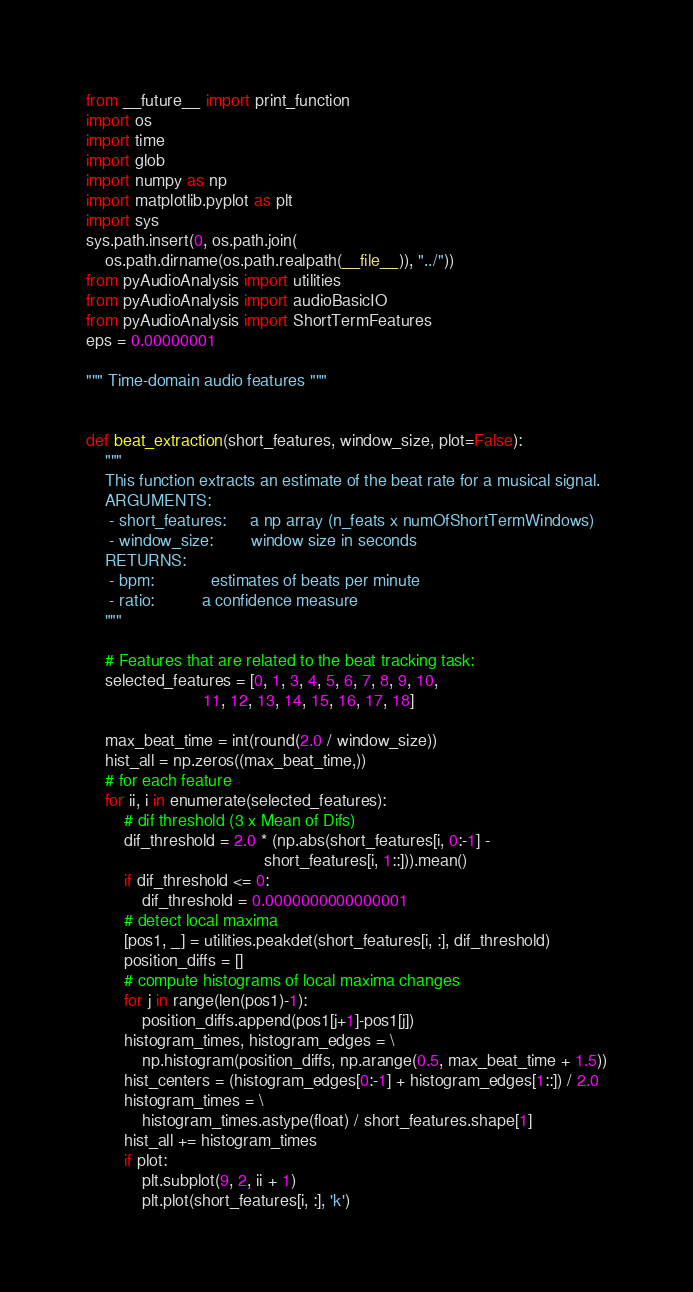Convert code to text. <code><loc_0><loc_0><loc_500><loc_500><_Python_>from __future__ import print_function
import os
import time
import glob
import numpy as np
import matplotlib.pyplot as plt
import sys
sys.path.insert(0, os.path.join(
    os.path.dirname(os.path.realpath(__file__)), "../"))
from pyAudioAnalysis import utilities
from pyAudioAnalysis import audioBasicIO
from pyAudioAnalysis import ShortTermFeatures
eps = 0.00000001

""" Time-domain audio features """


def beat_extraction(short_features, window_size, plot=False):
    """
    This function extracts an estimate of the beat rate for a musical signal.
    ARGUMENTS:
     - short_features:     a np array (n_feats x numOfShortTermWindows)
     - window_size:        window size in seconds
    RETURNS:
     - bpm:            estimates of beats per minute
     - ratio:          a confidence measure
    """

    # Features that are related to the beat tracking task:
    selected_features = [0, 1, 3, 4, 5, 6, 7, 8, 9, 10,
                         11, 12, 13, 14, 15, 16, 17, 18]

    max_beat_time = int(round(2.0 / window_size))
    hist_all = np.zeros((max_beat_time,))
    # for each feature
    for ii, i in enumerate(selected_features):
        # dif threshold (3 x Mean of Difs)
        dif_threshold = 2.0 * (np.abs(short_features[i, 0:-1] -
                                      short_features[i, 1::])).mean()
        if dif_threshold <= 0:
            dif_threshold = 0.0000000000000001
        # detect local maxima
        [pos1, _] = utilities.peakdet(short_features[i, :], dif_threshold)
        position_diffs = []
        # compute histograms of local maxima changes
        for j in range(len(pos1)-1):
            position_diffs.append(pos1[j+1]-pos1[j])
        histogram_times, histogram_edges = \
            np.histogram(position_diffs, np.arange(0.5, max_beat_time + 1.5))
        hist_centers = (histogram_edges[0:-1] + histogram_edges[1::]) / 2.0
        histogram_times = \
            histogram_times.astype(float) / short_features.shape[1]
        hist_all += histogram_times
        if plot:
            plt.subplot(9, 2, ii + 1)
            plt.plot(short_features[i, :], 'k')</code> 